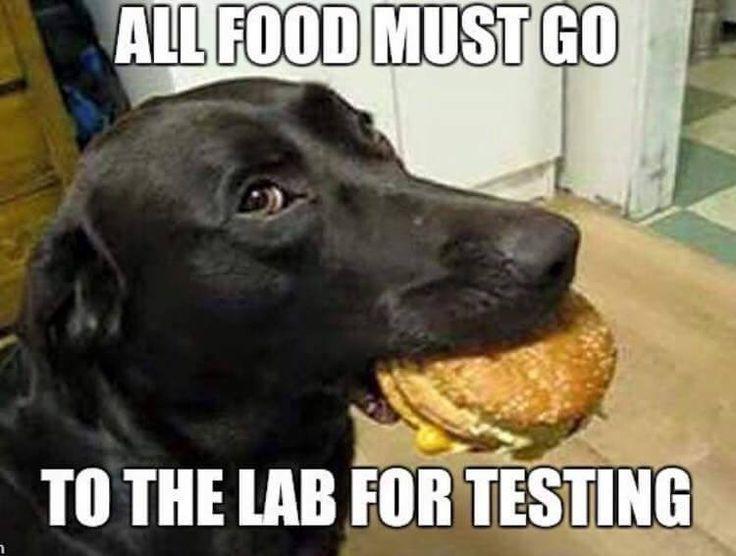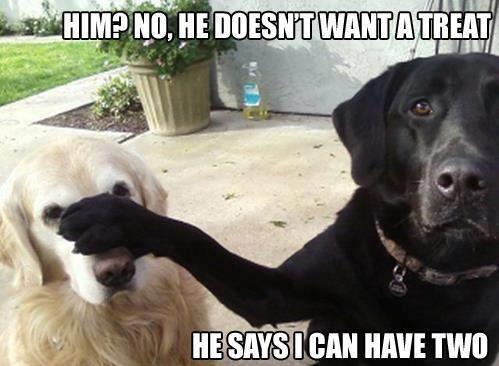The first image is the image on the left, the second image is the image on the right. For the images shown, is this caption "There are two dogs in the image on the left." true? Answer yes or no. No. 